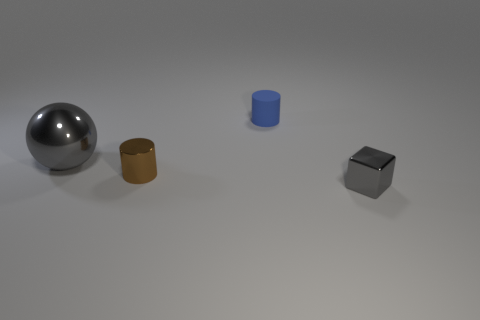Add 3 tiny blue rubber things. How many objects exist? 7 Subtract all blocks. How many objects are left? 3 Add 1 large gray metal spheres. How many large gray metal spheres are left? 2 Add 1 cubes. How many cubes exist? 2 Subtract 0 cyan balls. How many objects are left? 4 Subtract all large gray blocks. Subtract all tiny gray metal things. How many objects are left? 3 